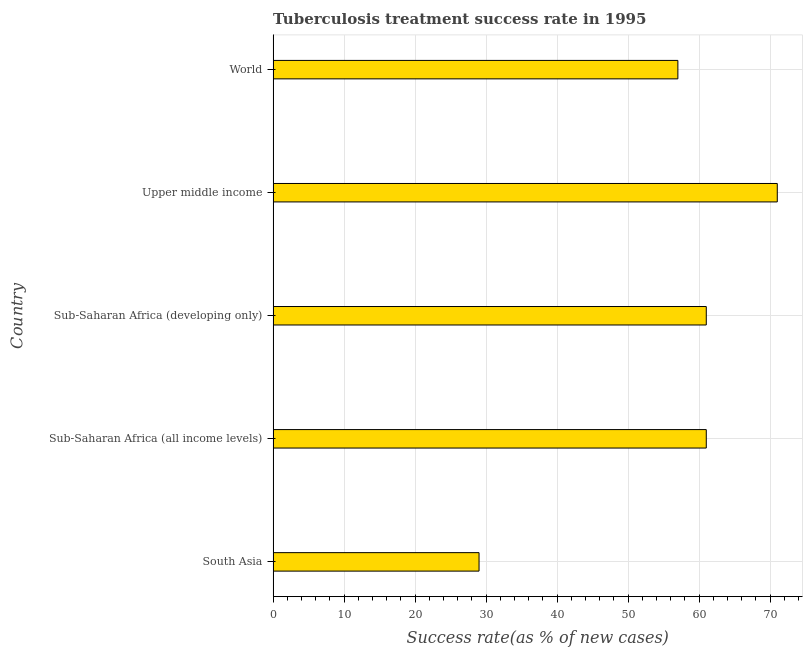Does the graph contain any zero values?
Make the answer very short. No. Does the graph contain grids?
Give a very brief answer. Yes. What is the title of the graph?
Provide a short and direct response. Tuberculosis treatment success rate in 1995. What is the label or title of the X-axis?
Offer a very short reply. Success rate(as % of new cases). Across all countries, what is the minimum tuberculosis treatment success rate?
Your response must be concise. 29. In which country was the tuberculosis treatment success rate maximum?
Provide a succinct answer. Upper middle income. What is the sum of the tuberculosis treatment success rate?
Your answer should be very brief. 279. What is the difference between the tuberculosis treatment success rate in Sub-Saharan Africa (all income levels) and Upper middle income?
Your response must be concise. -10. In how many countries, is the tuberculosis treatment success rate greater than 32 %?
Ensure brevity in your answer.  4. What is the ratio of the tuberculosis treatment success rate in Upper middle income to that in World?
Make the answer very short. 1.25. Is the tuberculosis treatment success rate in Sub-Saharan Africa (all income levels) less than that in Sub-Saharan Africa (developing only)?
Your answer should be compact. No. What is the difference between the highest and the lowest tuberculosis treatment success rate?
Offer a terse response. 42. How many bars are there?
Offer a terse response. 5. Are all the bars in the graph horizontal?
Offer a terse response. Yes. How many countries are there in the graph?
Provide a succinct answer. 5. What is the Success rate(as % of new cases) of South Asia?
Your response must be concise. 29. What is the Success rate(as % of new cases) of Sub-Saharan Africa (all income levels)?
Make the answer very short. 61. What is the Success rate(as % of new cases) of Upper middle income?
Ensure brevity in your answer.  71. What is the difference between the Success rate(as % of new cases) in South Asia and Sub-Saharan Africa (all income levels)?
Ensure brevity in your answer.  -32. What is the difference between the Success rate(as % of new cases) in South Asia and Sub-Saharan Africa (developing only)?
Give a very brief answer. -32. What is the difference between the Success rate(as % of new cases) in South Asia and Upper middle income?
Your response must be concise. -42. What is the difference between the Success rate(as % of new cases) in Sub-Saharan Africa (all income levels) and Sub-Saharan Africa (developing only)?
Your answer should be compact. 0. What is the difference between the Success rate(as % of new cases) in Sub-Saharan Africa (developing only) and World?
Make the answer very short. 4. What is the difference between the Success rate(as % of new cases) in Upper middle income and World?
Your response must be concise. 14. What is the ratio of the Success rate(as % of new cases) in South Asia to that in Sub-Saharan Africa (all income levels)?
Ensure brevity in your answer.  0.47. What is the ratio of the Success rate(as % of new cases) in South Asia to that in Sub-Saharan Africa (developing only)?
Give a very brief answer. 0.47. What is the ratio of the Success rate(as % of new cases) in South Asia to that in Upper middle income?
Ensure brevity in your answer.  0.41. What is the ratio of the Success rate(as % of new cases) in South Asia to that in World?
Ensure brevity in your answer.  0.51. What is the ratio of the Success rate(as % of new cases) in Sub-Saharan Africa (all income levels) to that in Upper middle income?
Offer a very short reply. 0.86. What is the ratio of the Success rate(as % of new cases) in Sub-Saharan Africa (all income levels) to that in World?
Offer a very short reply. 1.07. What is the ratio of the Success rate(as % of new cases) in Sub-Saharan Africa (developing only) to that in Upper middle income?
Your answer should be very brief. 0.86. What is the ratio of the Success rate(as % of new cases) in Sub-Saharan Africa (developing only) to that in World?
Provide a short and direct response. 1.07. What is the ratio of the Success rate(as % of new cases) in Upper middle income to that in World?
Provide a succinct answer. 1.25. 